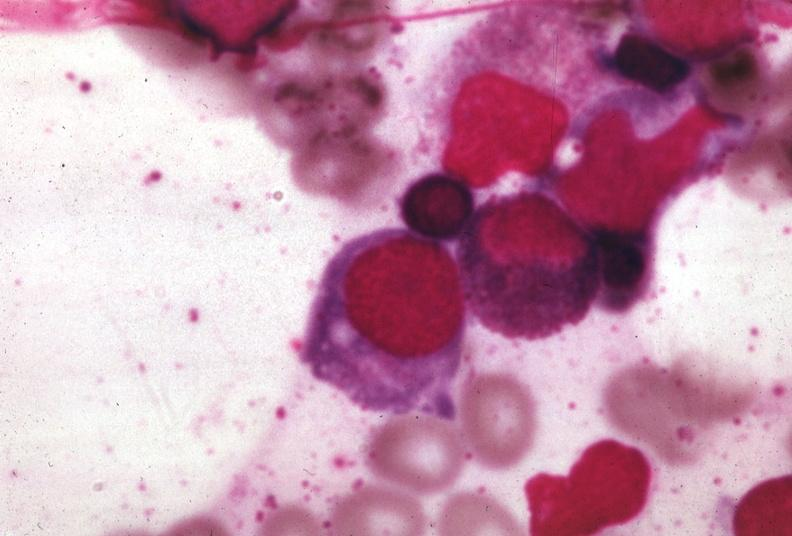what is present?
Answer the question using a single word or phrase. Bone marrow 